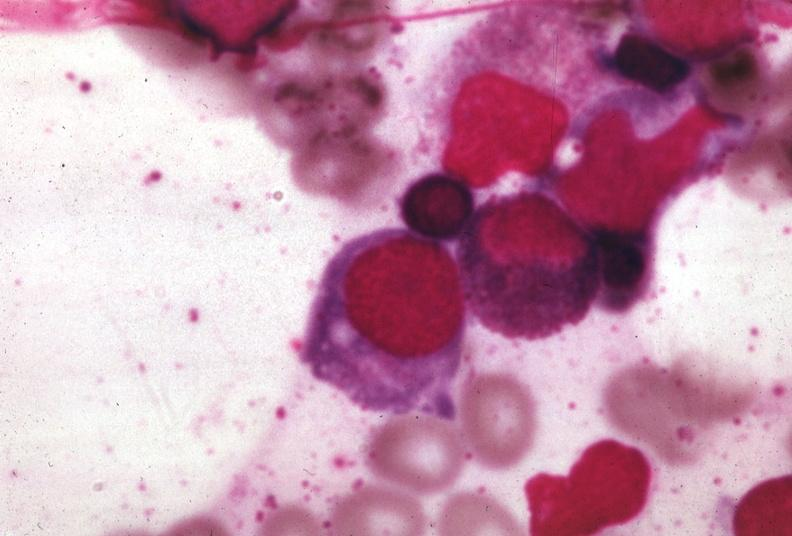what is present?
Answer the question using a single word or phrase. Bone marrow 